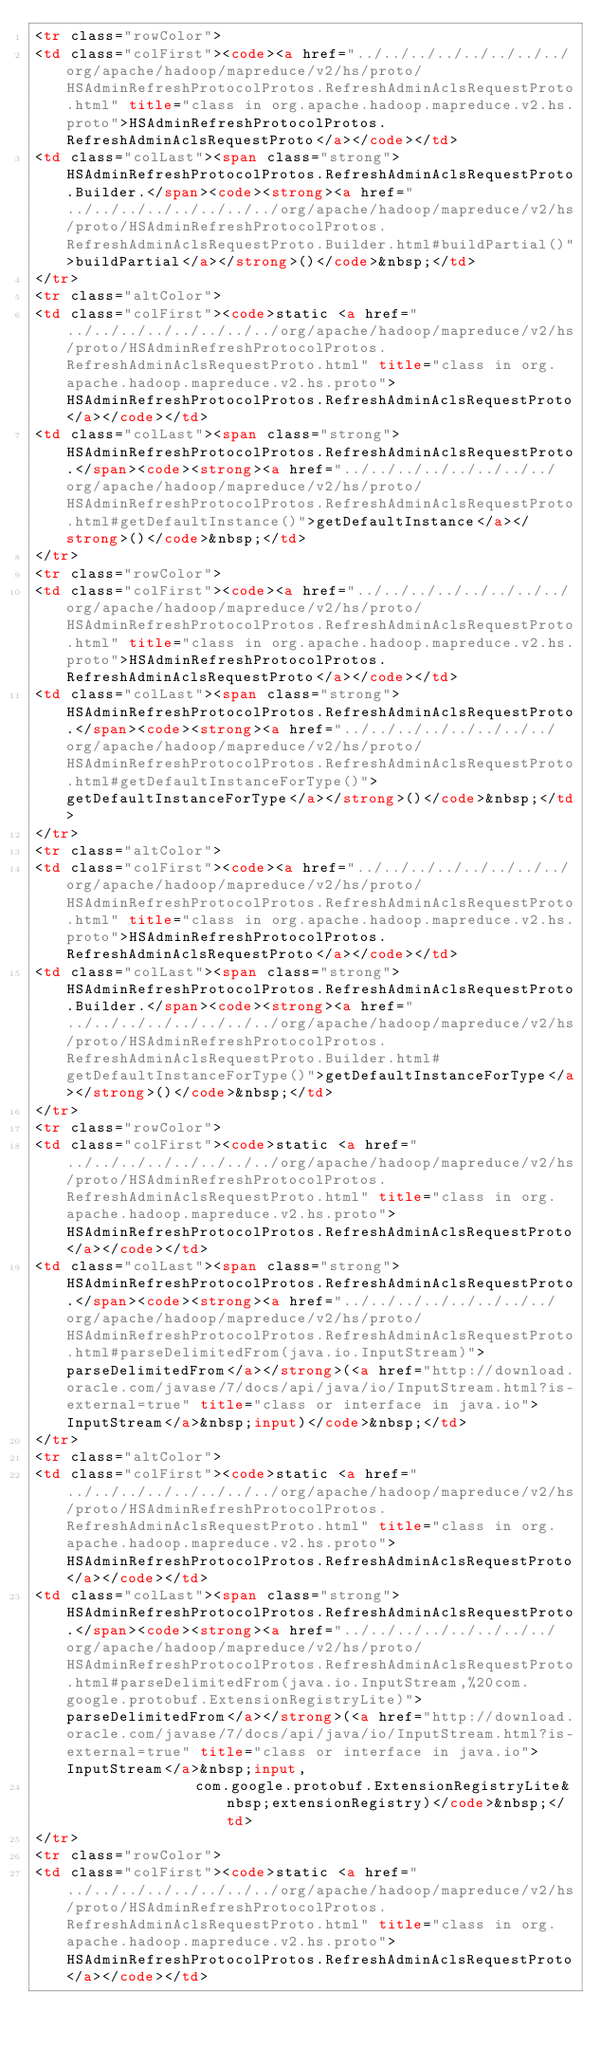Convert code to text. <code><loc_0><loc_0><loc_500><loc_500><_HTML_><tr class="rowColor">
<td class="colFirst"><code><a href="../../../../../../../../org/apache/hadoop/mapreduce/v2/hs/proto/HSAdminRefreshProtocolProtos.RefreshAdminAclsRequestProto.html" title="class in org.apache.hadoop.mapreduce.v2.hs.proto">HSAdminRefreshProtocolProtos.RefreshAdminAclsRequestProto</a></code></td>
<td class="colLast"><span class="strong">HSAdminRefreshProtocolProtos.RefreshAdminAclsRequestProto.Builder.</span><code><strong><a href="../../../../../../../../org/apache/hadoop/mapreduce/v2/hs/proto/HSAdminRefreshProtocolProtos.RefreshAdminAclsRequestProto.Builder.html#buildPartial()">buildPartial</a></strong>()</code>&nbsp;</td>
</tr>
<tr class="altColor">
<td class="colFirst"><code>static <a href="../../../../../../../../org/apache/hadoop/mapreduce/v2/hs/proto/HSAdminRefreshProtocolProtos.RefreshAdminAclsRequestProto.html" title="class in org.apache.hadoop.mapreduce.v2.hs.proto">HSAdminRefreshProtocolProtos.RefreshAdminAclsRequestProto</a></code></td>
<td class="colLast"><span class="strong">HSAdminRefreshProtocolProtos.RefreshAdminAclsRequestProto.</span><code><strong><a href="../../../../../../../../org/apache/hadoop/mapreduce/v2/hs/proto/HSAdminRefreshProtocolProtos.RefreshAdminAclsRequestProto.html#getDefaultInstance()">getDefaultInstance</a></strong>()</code>&nbsp;</td>
</tr>
<tr class="rowColor">
<td class="colFirst"><code><a href="../../../../../../../../org/apache/hadoop/mapreduce/v2/hs/proto/HSAdminRefreshProtocolProtos.RefreshAdminAclsRequestProto.html" title="class in org.apache.hadoop.mapreduce.v2.hs.proto">HSAdminRefreshProtocolProtos.RefreshAdminAclsRequestProto</a></code></td>
<td class="colLast"><span class="strong">HSAdminRefreshProtocolProtos.RefreshAdminAclsRequestProto.</span><code><strong><a href="../../../../../../../../org/apache/hadoop/mapreduce/v2/hs/proto/HSAdminRefreshProtocolProtos.RefreshAdminAclsRequestProto.html#getDefaultInstanceForType()">getDefaultInstanceForType</a></strong>()</code>&nbsp;</td>
</tr>
<tr class="altColor">
<td class="colFirst"><code><a href="../../../../../../../../org/apache/hadoop/mapreduce/v2/hs/proto/HSAdminRefreshProtocolProtos.RefreshAdminAclsRequestProto.html" title="class in org.apache.hadoop.mapreduce.v2.hs.proto">HSAdminRefreshProtocolProtos.RefreshAdminAclsRequestProto</a></code></td>
<td class="colLast"><span class="strong">HSAdminRefreshProtocolProtos.RefreshAdminAclsRequestProto.Builder.</span><code><strong><a href="../../../../../../../../org/apache/hadoop/mapreduce/v2/hs/proto/HSAdminRefreshProtocolProtos.RefreshAdminAclsRequestProto.Builder.html#getDefaultInstanceForType()">getDefaultInstanceForType</a></strong>()</code>&nbsp;</td>
</tr>
<tr class="rowColor">
<td class="colFirst"><code>static <a href="../../../../../../../../org/apache/hadoop/mapreduce/v2/hs/proto/HSAdminRefreshProtocolProtos.RefreshAdminAclsRequestProto.html" title="class in org.apache.hadoop.mapreduce.v2.hs.proto">HSAdminRefreshProtocolProtos.RefreshAdminAclsRequestProto</a></code></td>
<td class="colLast"><span class="strong">HSAdminRefreshProtocolProtos.RefreshAdminAclsRequestProto.</span><code><strong><a href="../../../../../../../../org/apache/hadoop/mapreduce/v2/hs/proto/HSAdminRefreshProtocolProtos.RefreshAdminAclsRequestProto.html#parseDelimitedFrom(java.io.InputStream)">parseDelimitedFrom</a></strong>(<a href="http://download.oracle.com/javase/7/docs/api/java/io/InputStream.html?is-external=true" title="class or interface in java.io">InputStream</a>&nbsp;input)</code>&nbsp;</td>
</tr>
<tr class="altColor">
<td class="colFirst"><code>static <a href="../../../../../../../../org/apache/hadoop/mapreduce/v2/hs/proto/HSAdminRefreshProtocolProtos.RefreshAdminAclsRequestProto.html" title="class in org.apache.hadoop.mapreduce.v2.hs.proto">HSAdminRefreshProtocolProtos.RefreshAdminAclsRequestProto</a></code></td>
<td class="colLast"><span class="strong">HSAdminRefreshProtocolProtos.RefreshAdminAclsRequestProto.</span><code><strong><a href="../../../../../../../../org/apache/hadoop/mapreduce/v2/hs/proto/HSAdminRefreshProtocolProtos.RefreshAdminAclsRequestProto.html#parseDelimitedFrom(java.io.InputStream,%20com.google.protobuf.ExtensionRegistryLite)">parseDelimitedFrom</a></strong>(<a href="http://download.oracle.com/javase/7/docs/api/java/io/InputStream.html?is-external=true" title="class or interface in java.io">InputStream</a>&nbsp;input,
                  com.google.protobuf.ExtensionRegistryLite&nbsp;extensionRegistry)</code>&nbsp;</td>
</tr>
<tr class="rowColor">
<td class="colFirst"><code>static <a href="../../../../../../../../org/apache/hadoop/mapreduce/v2/hs/proto/HSAdminRefreshProtocolProtos.RefreshAdminAclsRequestProto.html" title="class in org.apache.hadoop.mapreduce.v2.hs.proto">HSAdminRefreshProtocolProtos.RefreshAdminAclsRequestProto</a></code></td></code> 